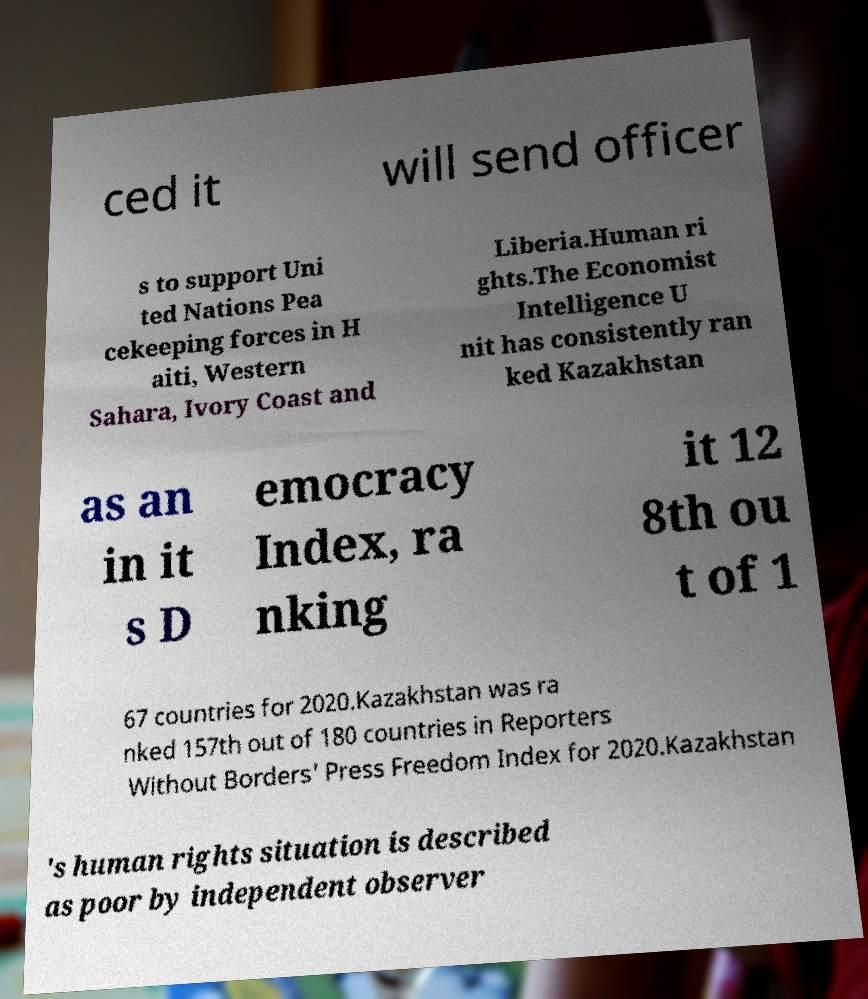There's text embedded in this image that I need extracted. Can you transcribe it verbatim? ced it will send officer s to support Uni ted Nations Pea cekeeping forces in H aiti, Western Sahara, Ivory Coast and Liberia.Human ri ghts.The Economist Intelligence U nit has consistently ran ked Kazakhstan as an in it s D emocracy Index, ra nking it 12 8th ou t of 1 67 countries for 2020.Kazakhstan was ra nked 157th out of 180 countries in Reporters Without Borders' Press Freedom Index for 2020.Kazakhstan 's human rights situation is described as poor by independent observer 